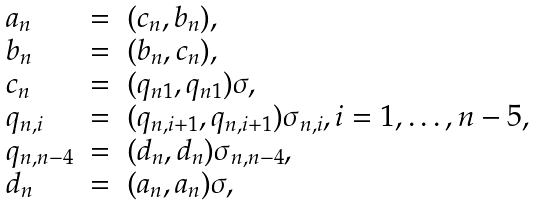<formula> <loc_0><loc_0><loc_500><loc_500>\begin{array} { l c l } a _ { n } & = & ( c _ { n } , b _ { n } ) , \\ b _ { n } & = & ( b _ { n } , c _ { n } ) , \\ c _ { n } & = & ( q _ { n 1 } , q _ { n 1 } ) \sigma , \\ q _ { n , i } & = & ( q _ { n , i + 1 } , q _ { n , i + 1 } ) \sigma _ { n , i } , i = 1 , \dots , n - 5 , \\ q _ { n , n - 4 } & = & ( d _ { n } , d _ { n } ) \sigma _ { n , n - 4 } , \\ d _ { n } & = & ( a _ { n } , a _ { n } ) \sigma , \\ \end{array}</formula> 